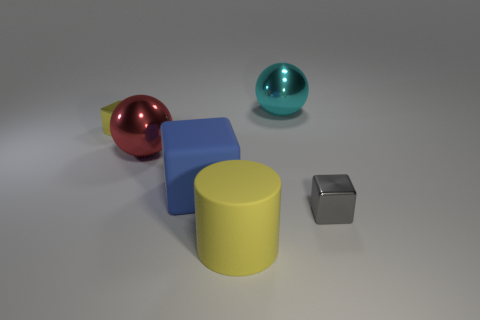Add 1 big red metal spheres. How many objects exist? 7 Subtract all cylinders. How many objects are left? 5 Add 3 yellow matte objects. How many yellow matte objects are left? 4 Add 1 small yellow things. How many small yellow things exist? 2 Subtract 0 purple blocks. How many objects are left? 6 Subtract all big cylinders. Subtract all large matte cylinders. How many objects are left? 4 